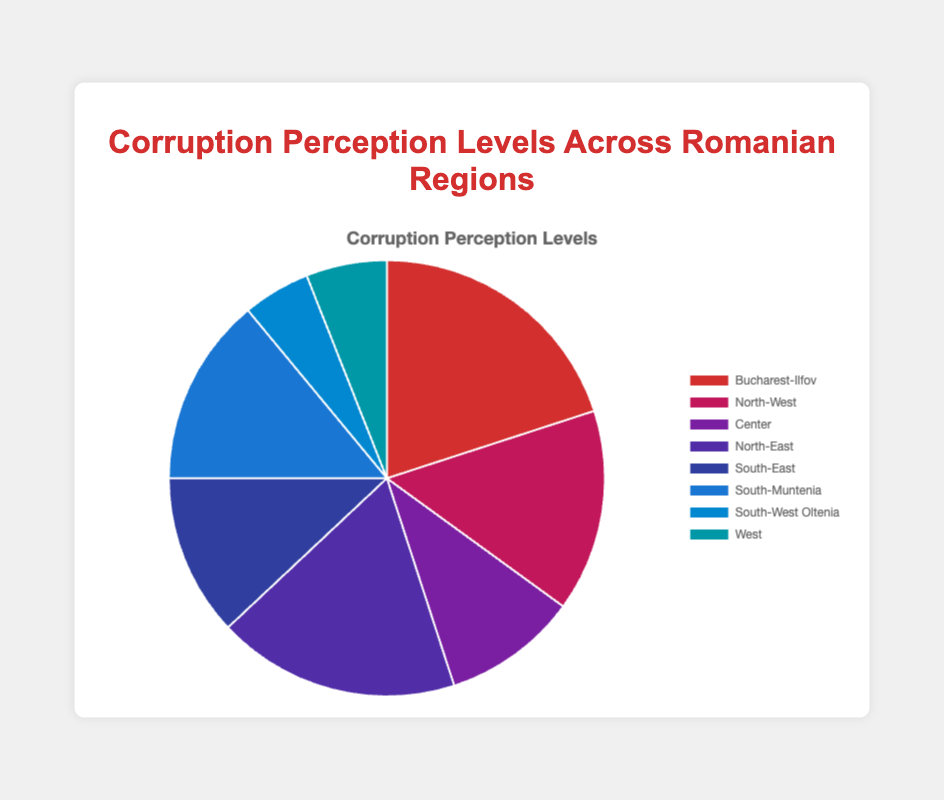What region has the highest corruption perception level? Look at the pie chart and identify the region with the largest slice. The largest slice appears to be Bucharest-Ilfov with a corruption perception level of 20%.
Answer: Bucharest-Ilfov Which region has the lowest corruption perception level? Look at the pie chart and find the smallest slice. The smallest slice belongs to South-West Oltenia, which has a corruption perception level of 5%.
Answer: South-West Oltenia What is the total corruption perception level for all regions combined? Sum the corruption perception levels of all listed regions: 20 (Bucharest-Ilfov) + 15 (North-West) + 10 (Center) + 18 (North-East) + 12 (South-East) + 14 (South-Muntenia) + 5 (South-West Oltenia) + 6 (West) = 100%.
Answer: 100% Which region has a corruption perception level closest to the average for all regions? Find the average corruption perception level by summing all values and dividing by the number of regions: (20 + 15 + 10 + 18 + 12 + 14 + 5 + 6) / 8 = 12.5%. The region with the value closest to 12.5% is South-East with 12%.
Answer: South-East Which regions have corruption perception levels greater than 15%? Identify regions from the pie chart whose slices are labeled with percentages greater than 15%. These regions are Bucharest-Ilfov (20%) and North-East (18%).
Answer: Bucharest-Ilfov, North-East What is the difference in corruption perception levels between the Bucharest-Ilfov region and the West region? Subtract the corruption perception level of the West (6%) from Bucharest-Ilfov (20%): 20% - 6% = 14%.
Answer: 14% How does the corruption perception level of North-West compare to South-Muntenia? Compare the slices labeled North-West (15%) and South-Muntenia (14%) to determine which is larger. North-West has a slightly higher corruption perception level than South-Muntenia.
Answer: North-West is greater Which region's corruption perception level is right in between South-Muntenia and Center? South-Muntenia has a level of 14% and Center has 10%. The average of these values is (14% + 10%) / 2 = 12%. The region with a corruption perception level closest to 12% is South-East (12%).
Answer: South-East What is the combined corruption perception level of the South-West Oltenia and West regions? Add the corruption perception levels of South-West Oltenia (5%) and West (6%): 5% + 6% = 11%.
Answer: 11% 